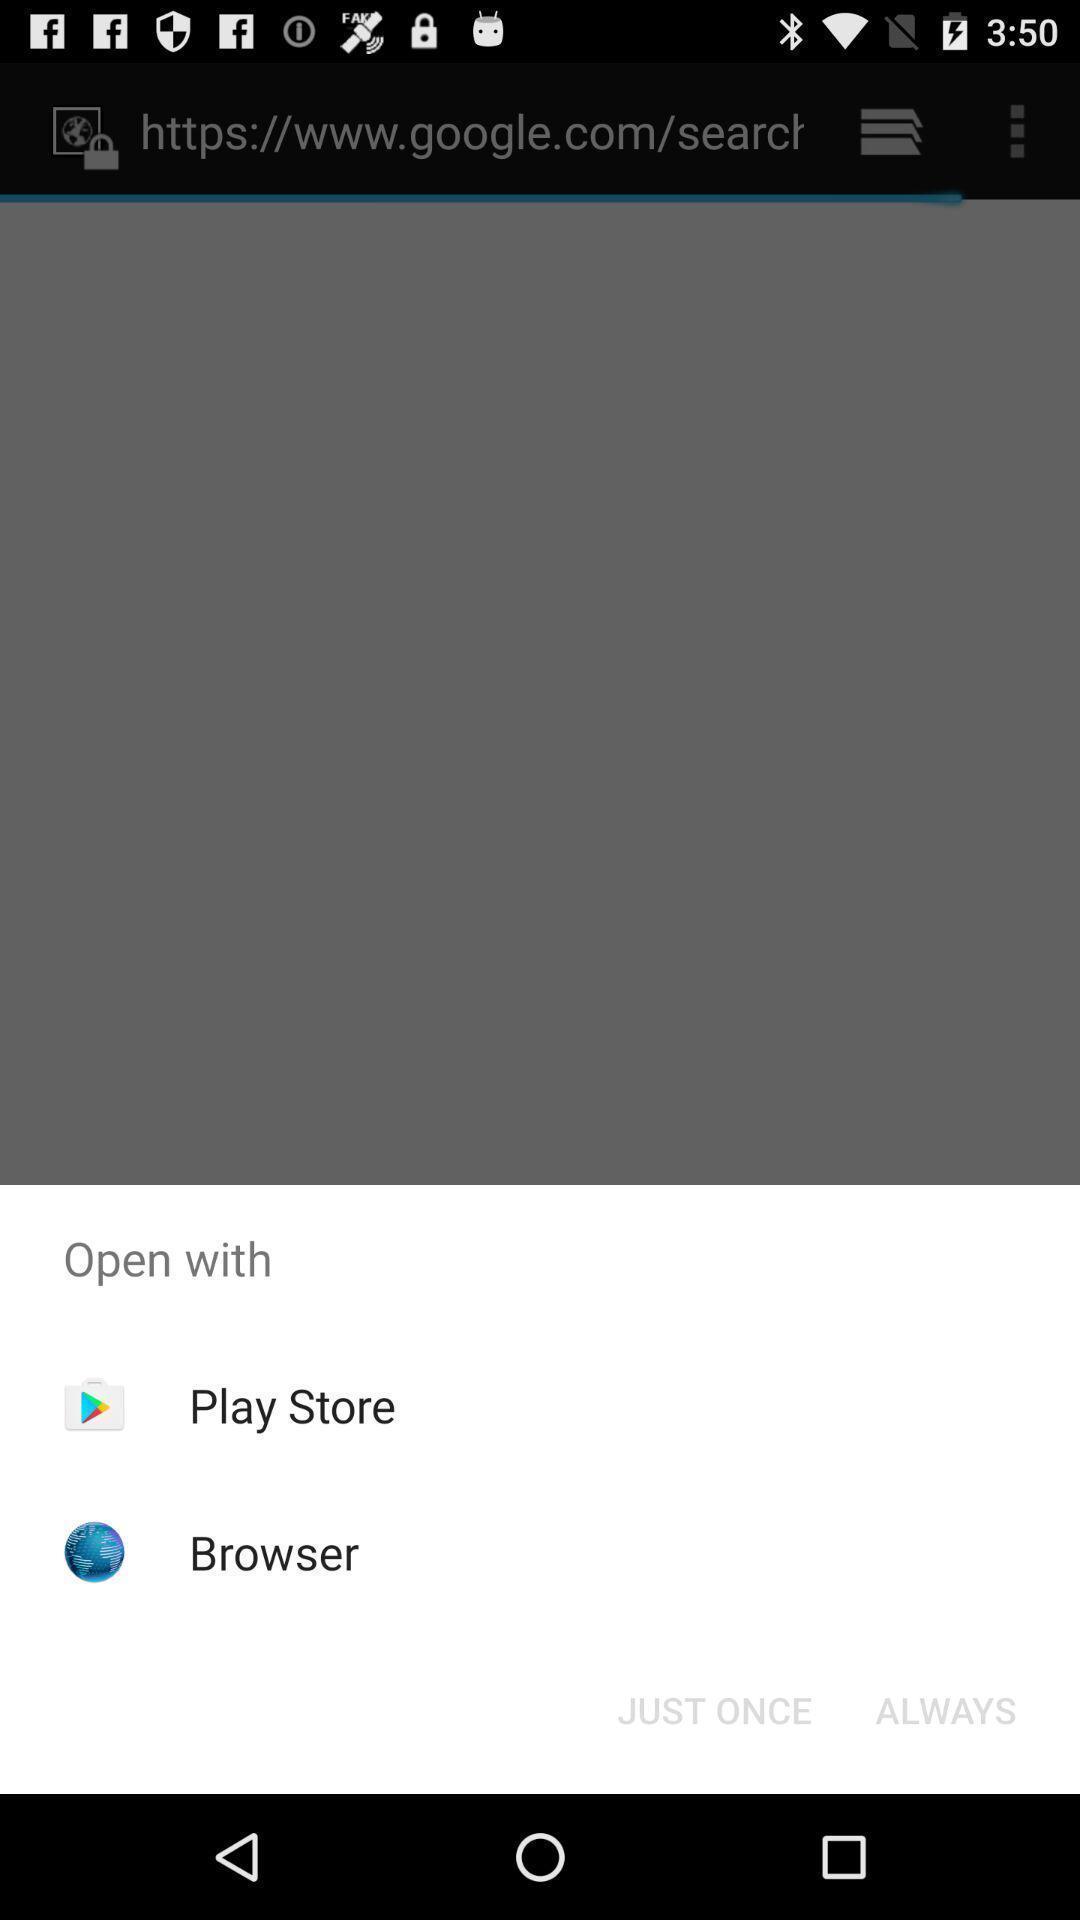Summarize the main components in this picture. Pop-up to open app via different browsers. 